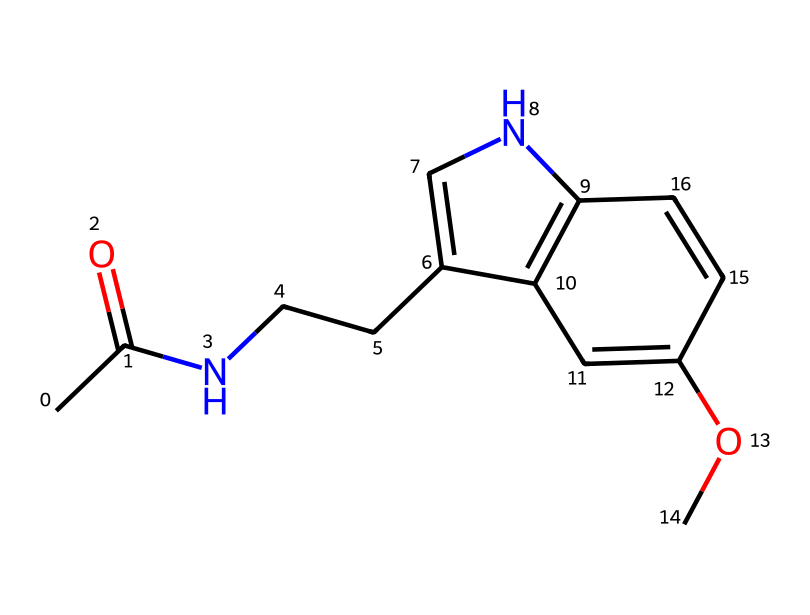what is the molecular formula of this structure? To find the molecular formula, we count the different types of atoms in the SMILES representation. The structure includes carbon (C), hydrogen (H), nitrogen (N), and oxygen (O) atoms. By counting, we determine there are 13 carbons, 16 hydrogens, 2 nitrogens, and 1 oxygen. Therefore, the molecular formula is C13H16N2O.
Answer: C13H16N2O how many rings are present in this chemical structure? The structure contains two cyclical components connected by a bridge. By analyzing the SMILES notation, we identify that it includes a five-membered ring (the pyrrole-like ring) and an adjacent six-membered aromatic ring. Thus, there are a total of two rings in this chemical structure.
Answer: 2 what functional groups can be identified in this compound? The chemical structure exhibits several functional groups, including an amide group (from the carbonyl and nitrogen) and a methoxy group (from the -OCH3). By analyzing the bonds and atoms, we can see that these functional groups are present.
Answer: amide, methoxy does this chemical contain nitrogen atoms? The SMILES representation contains two nitrogen atoms, which can be confirmed by observing the two instances of 'N' in the notation. Therefore, this chemical does indeed have nitrogen atoms.
Answer: yes is melatonin considered an alkaloid? Melatonin falls under the category of tryptamine alkaloids, which are characterized by their structure containing nitrogen and often derived from amino acids. The presence of nitrogen in the core structure confirms that melatonin is indeed classified as an alkaloid.
Answer: yes what role does this compound play in the human body? Melatonin is primarily associated with the regulation of sleep-wake cycles. It is produced in the pineal gland in response to darkness and helps in signaling the body to prepare for sleep, influencing circadian rhythms.
Answer: sleep regulation 